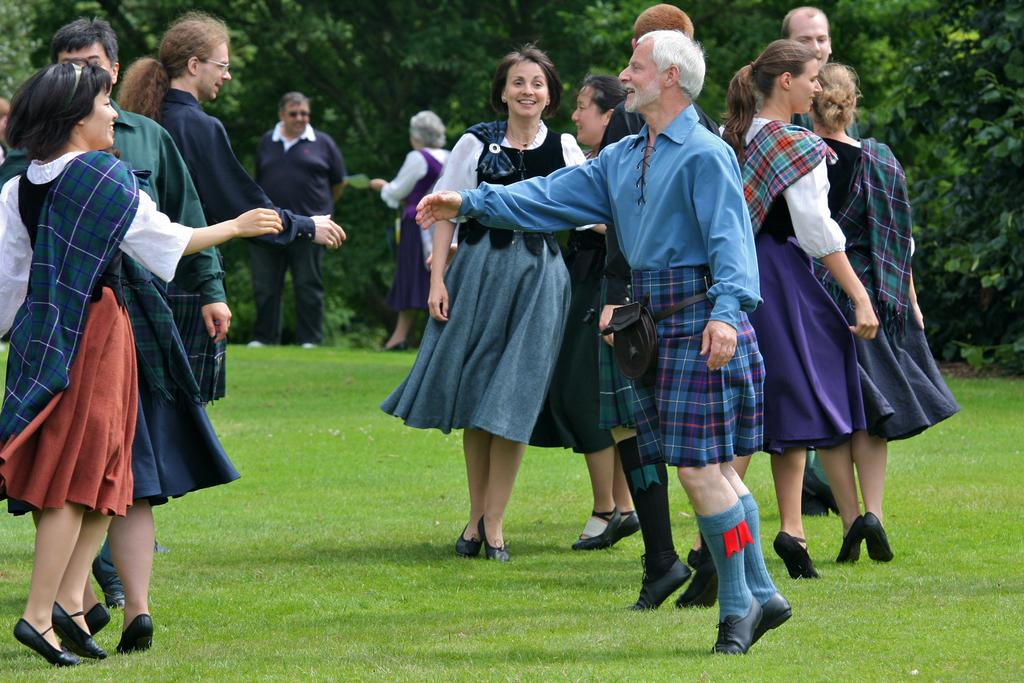What are the people in the image doing? The people in the image are dancing. Where is the dancing taking place? The dancing is taking place on a grass path. Are there any other people in the image besides those dancing? Yes, there are people standing in the image. What can be seen in the background of the image? Trees are visible in the background of the image. What type of apparatus is being used by the dancers in the image? There is no apparatus visible in the image; the people are dancing on a grass path. What impulse led the people to start dancing in the image? The image does not provide information about the reason or impulse for the dancing. 